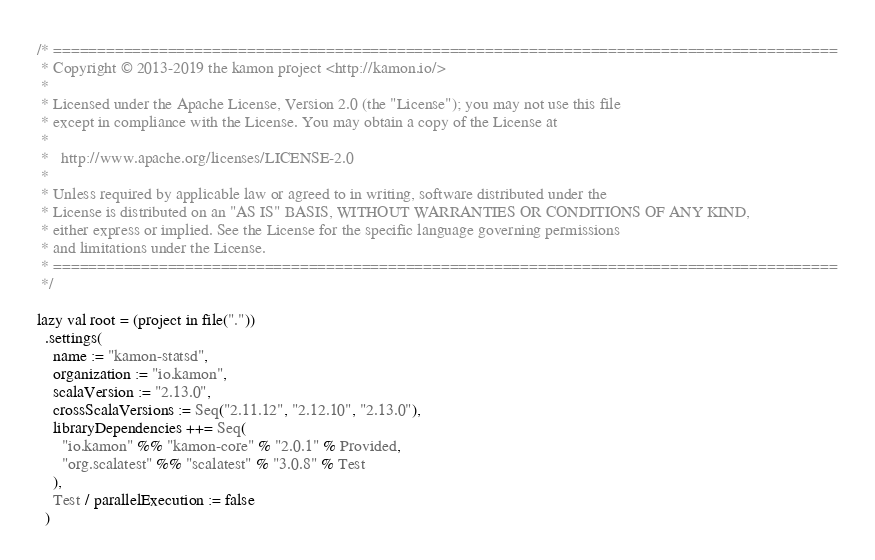<code> <loc_0><loc_0><loc_500><loc_500><_Scala_>/* =========================================================================================
 * Copyright © 2013-2019 the kamon project <http://kamon.io/>
 *
 * Licensed under the Apache License, Version 2.0 (the "License"); you may not use this file
 * except in compliance with the License. You may obtain a copy of the License at
 *
 *   http://www.apache.org/licenses/LICENSE-2.0
 *
 * Unless required by applicable law or agreed to in writing, software distributed under the
 * License is distributed on an "AS IS" BASIS, WITHOUT WARRANTIES OR CONDITIONS OF ANY KIND,
 * either express or implied. See the License for the specific language governing permissions
 * and limitations under the License.
 * =========================================================================================
 */

lazy val root = (project in file("."))
  .settings(
    name := "kamon-statsd",
    organization := "io.kamon",
    scalaVersion := "2.13.0",
    crossScalaVersions := Seq("2.11.12", "2.12.10", "2.13.0"),
    libraryDependencies ++= Seq(
      "io.kamon" %% "kamon-core" % "2.0.1" % Provided,
      "org.scalatest" %% "scalatest" % "3.0.8" % Test
    ),
    Test / parallelExecution := false
  )
</code> 